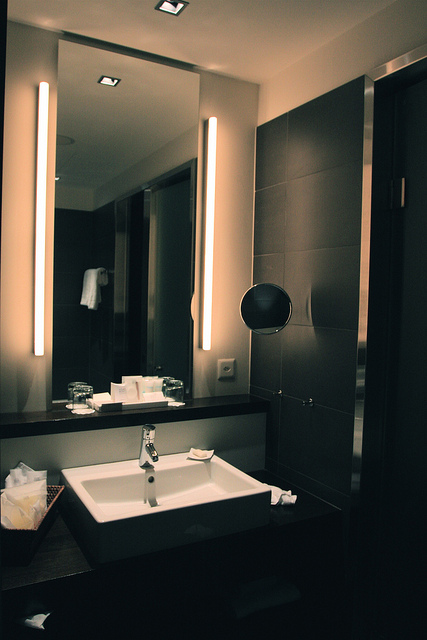Based on the design, who do you think primarily uses this bathroom? Based on the design, this bathroom likely caters to adults who appreciate a modern, stylish, and functional space. The multiple soap dispensers and extensive mirrors suggest it could be shared by a couple or multiple occupants, possibly in a high-end apartment or hotel. The sophisticated design elements indicate that the users likely value aesthetics and luxury in their personal spaces. 